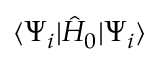<formula> <loc_0><loc_0><loc_500><loc_500>\langle \Psi _ { i } | \hat { H } _ { 0 } | \Psi _ { i } \rangle</formula> 